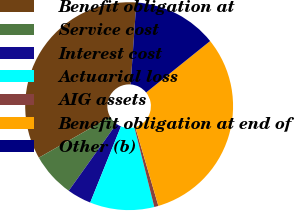<chart> <loc_0><loc_0><loc_500><loc_500><pie_chart><fcel>Benefit obligation at<fcel>Service cost<fcel>Interest cost<fcel>Actuarial loss<fcel>AIG assets<fcel>Benefit obligation at end of<fcel>Other (b)<nl><fcel>34.36%<fcel>6.88%<fcel>3.76%<fcel>10.0%<fcel>0.65%<fcel>31.24%<fcel>13.12%<nl></chart> 